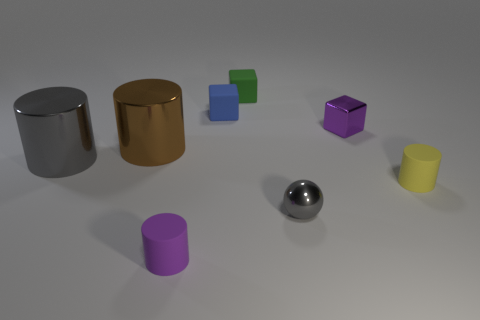Add 2 purple metal objects. How many objects exist? 10 Subtract all spheres. How many objects are left? 7 Subtract all tiny yellow cylinders. Subtract all yellow objects. How many objects are left? 6 Add 7 small shiny blocks. How many small shiny blocks are left? 8 Add 8 yellow rubber cylinders. How many yellow rubber cylinders exist? 9 Subtract 0 cyan cylinders. How many objects are left? 8 